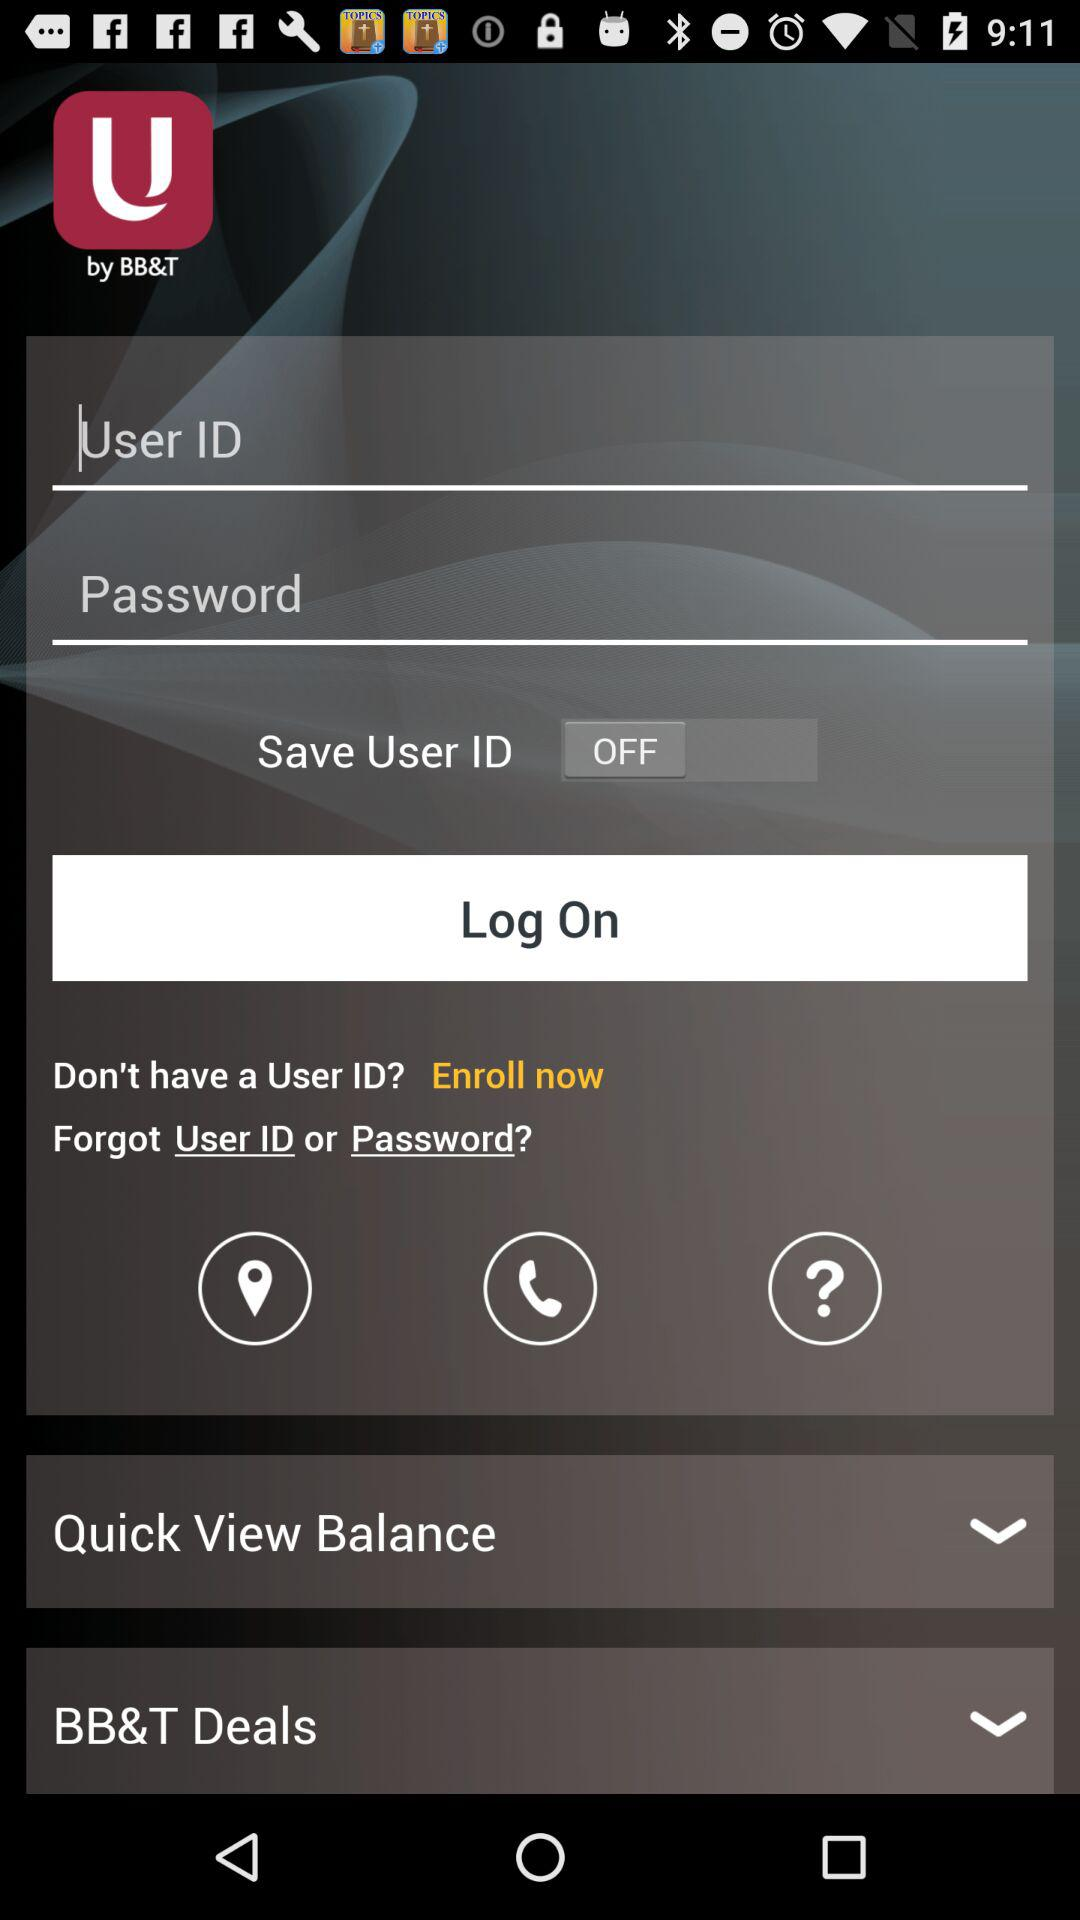What is the status of "Save User ID"? "Save User ID" is turned off. 